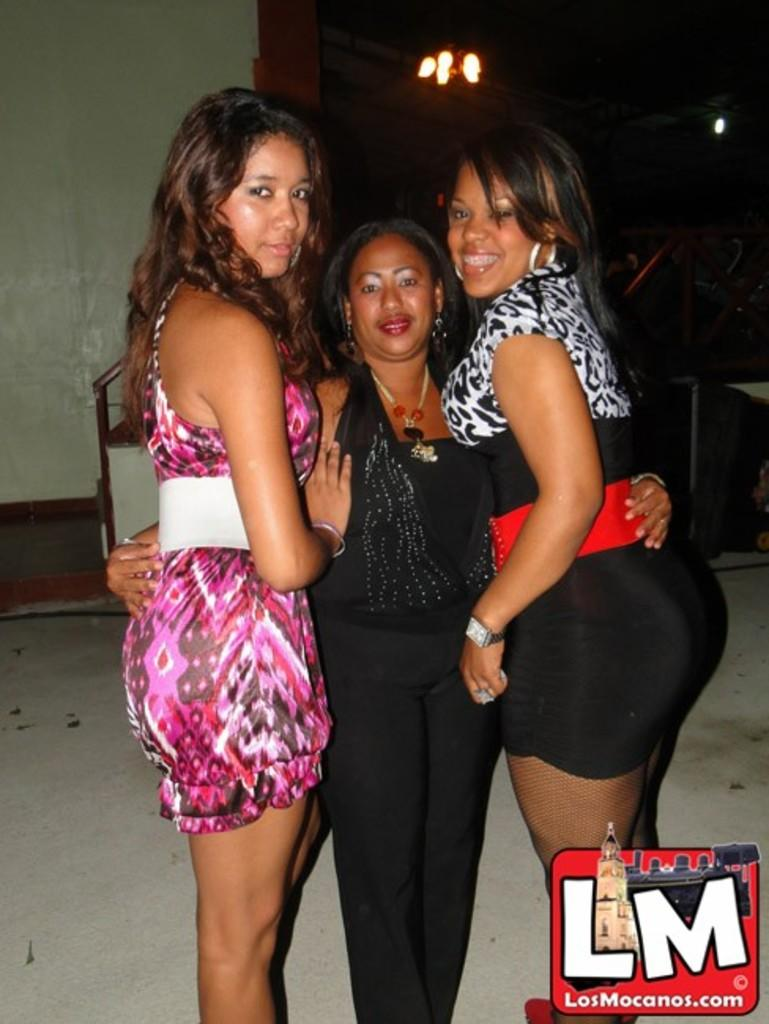How many women are in the image? There are three women in the image. What are the women doing in the image? The women are standing and smiling. What can be seen in the background of the image? There is a wall in the background of the image. What is on the wall in the image? There is a light on the wall. What is the shape of the daughter's toy in the image? There is no daughter or toy present in the image. 